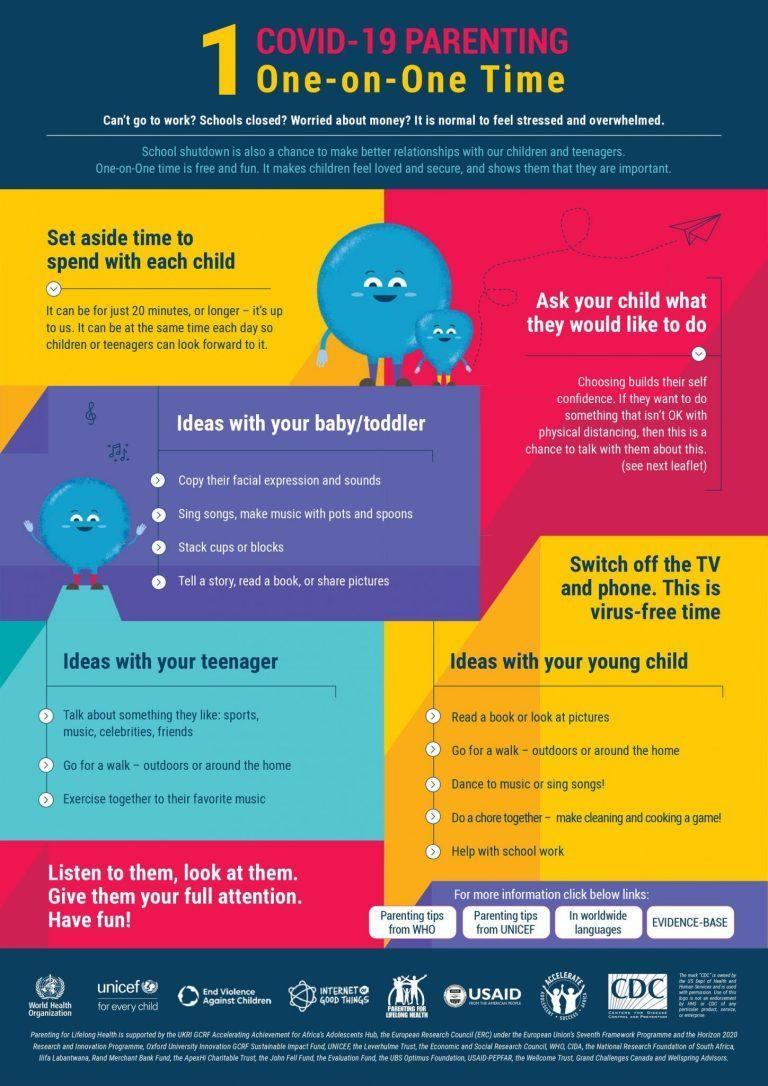Who needs help with school work - toddler, teenager, young child or parent?
Answer the question with a short phrase. Young child At which stages of childhood, would children love to read a book? Baby/toddler, young child What are the 3 stages of childhood? Baby/toddler, young child, teenager At which stage of childhood, would a child enjoy someone imitating his facial expression? Baby/toddler How many ideas of spending time with your young child are mentioned? 5 What are the two gadgets you shouldn't use while spending time with your children? TV and phone How many ideas of spending time with your teenager are mentioned? 3 What are some of the good topics, for conversation with your teenager? Sports, music, celebrities, friends At which stages of childhood, would children love to go for a walk? Teenager, young child Which is the second Idea under 'ideas with your baby toddler'? Singh songs, make music with pots and spoons Which is the third idea under 'ideas with your baby toddler'? Stack cups or blocks How many ideas of spending time with your toddler are mentioned here? 4 How many stages of childhood are mentioned? 3 Which are the two organisations that provide 'parenting tips'? UNICEF, WHO What are the first 2 ideas of spending time with your young child? Read a book or look at pictures, go for a walk - outdoors or around the home What is the minimum quality time you should have with your child? 20 minutes 